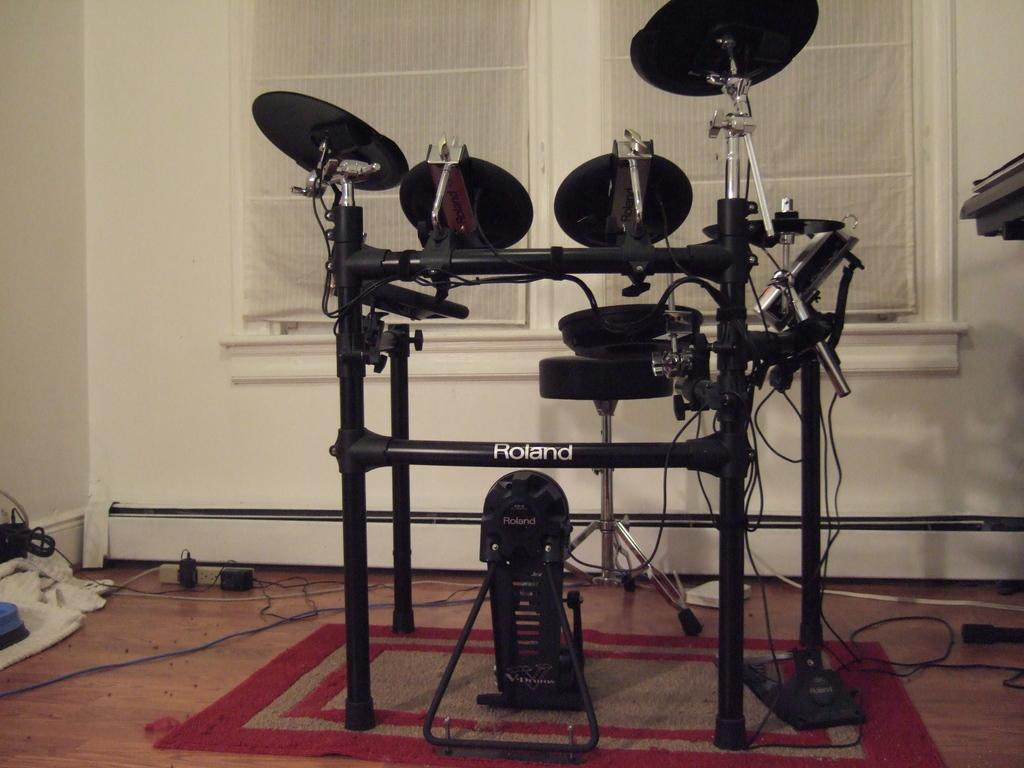What type of furniture is in the image? There is a stool in the image. What is on the floor in the image? There are objects on the floor in the image. What can be seen hanging in the image? Wires and rods are present in the image. What is covering the floor in the image? There is a mat in the image. What type of material is visible in the image? There is cloth in the image. What is visible in the background of the image? There are windows with curtains and a wall visible in the background of the image. What type of bushes can be seen growing near the stool in the image? There are no bushes visible in the image; it only features a stool, a mat, wires, rods, cloth, objects on the floor, windows with curtains, and a wall in the background. What route is the stool taking in the image? The stool is not taking any route; it is stationary in the image. 